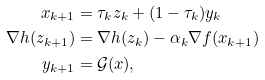Convert formula to latex. <formula><loc_0><loc_0><loc_500><loc_500>x _ { k + 1 } & = \tau _ { k } z _ { k } + ( 1 - \tau _ { k } ) y _ { k } \\ \nabla h ( z _ { k + 1 } ) & = \nabla h ( z _ { k } ) - \alpha _ { k } \nabla f ( x _ { k + 1 } ) \\ y _ { k + 1 } & = \mathcal { G } ( x ) ,</formula> 